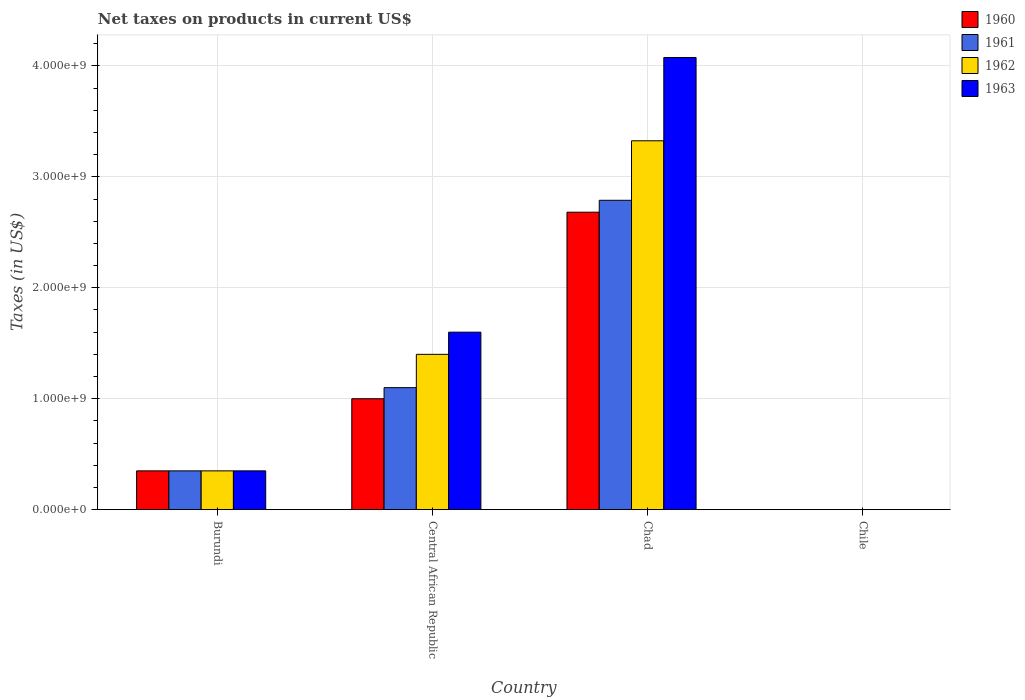How many different coloured bars are there?
Offer a terse response. 4. How many groups of bars are there?
Provide a short and direct response. 4. Are the number of bars per tick equal to the number of legend labels?
Provide a short and direct response. Yes. How many bars are there on the 3rd tick from the right?
Provide a short and direct response. 4. In how many cases, is the number of bars for a given country not equal to the number of legend labels?
Your answer should be compact. 0. What is the net taxes on products in 1963 in Chile?
Offer a terse response. 3.54e+05. Across all countries, what is the maximum net taxes on products in 1963?
Make the answer very short. 4.08e+09. Across all countries, what is the minimum net taxes on products in 1961?
Keep it short and to the point. 2.53e+05. In which country was the net taxes on products in 1961 maximum?
Give a very brief answer. Chad. In which country was the net taxes on products in 1962 minimum?
Make the answer very short. Chile. What is the total net taxes on products in 1962 in the graph?
Keep it short and to the point. 5.08e+09. What is the difference between the net taxes on products in 1960 in Central African Republic and that in Chile?
Keep it short and to the point. 1.00e+09. What is the difference between the net taxes on products in 1962 in Chad and the net taxes on products in 1963 in Chile?
Your answer should be very brief. 3.32e+09. What is the average net taxes on products in 1962 per country?
Your answer should be compact. 1.27e+09. What is the difference between the net taxes on products of/in 1960 and net taxes on products of/in 1961 in Chad?
Your answer should be compact. -1.07e+08. In how many countries, is the net taxes on products in 1960 greater than 1400000000 US$?
Give a very brief answer. 1. What is the ratio of the net taxes on products in 1962 in Burundi to that in Chad?
Offer a terse response. 0.11. Is the net taxes on products in 1962 in Burundi less than that in Central African Republic?
Offer a terse response. Yes. Is the difference between the net taxes on products in 1960 in Burundi and Central African Republic greater than the difference between the net taxes on products in 1961 in Burundi and Central African Republic?
Give a very brief answer. Yes. What is the difference between the highest and the second highest net taxes on products in 1963?
Offer a very short reply. 2.48e+09. What is the difference between the highest and the lowest net taxes on products in 1963?
Give a very brief answer. 4.08e+09. In how many countries, is the net taxes on products in 1963 greater than the average net taxes on products in 1963 taken over all countries?
Ensure brevity in your answer.  2. What does the 4th bar from the left in Chad represents?
Give a very brief answer. 1963. What does the 1st bar from the right in Burundi represents?
Keep it short and to the point. 1963. Is it the case that in every country, the sum of the net taxes on products in 1960 and net taxes on products in 1963 is greater than the net taxes on products in 1962?
Your response must be concise. Yes. How many countries are there in the graph?
Your response must be concise. 4. Are the values on the major ticks of Y-axis written in scientific E-notation?
Provide a succinct answer. Yes. Does the graph contain grids?
Offer a terse response. Yes. What is the title of the graph?
Your answer should be compact. Net taxes on products in current US$. Does "1960" appear as one of the legend labels in the graph?
Your answer should be very brief. Yes. What is the label or title of the X-axis?
Ensure brevity in your answer.  Country. What is the label or title of the Y-axis?
Keep it short and to the point. Taxes (in US$). What is the Taxes (in US$) in 1960 in Burundi?
Your answer should be compact. 3.50e+08. What is the Taxes (in US$) of 1961 in Burundi?
Give a very brief answer. 3.50e+08. What is the Taxes (in US$) of 1962 in Burundi?
Keep it short and to the point. 3.50e+08. What is the Taxes (in US$) of 1963 in Burundi?
Offer a terse response. 3.50e+08. What is the Taxes (in US$) of 1960 in Central African Republic?
Provide a succinct answer. 1.00e+09. What is the Taxes (in US$) in 1961 in Central African Republic?
Provide a succinct answer. 1.10e+09. What is the Taxes (in US$) of 1962 in Central African Republic?
Your answer should be compact. 1.40e+09. What is the Taxes (in US$) of 1963 in Central African Republic?
Provide a succinct answer. 1.60e+09. What is the Taxes (in US$) of 1960 in Chad?
Keep it short and to the point. 2.68e+09. What is the Taxes (in US$) in 1961 in Chad?
Ensure brevity in your answer.  2.79e+09. What is the Taxes (in US$) in 1962 in Chad?
Make the answer very short. 3.32e+09. What is the Taxes (in US$) in 1963 in Chad?
Ensure brevity in your answer.  4.08e+09. What is the Taxes (in US$) of 1960 in Chile?
Provide a short and direct response. 2.02e+05. What is the Taxes (in US$) in 1961 in Chile?
Keep it short and to the point. 2.53e+05. What is the Taxes (in US$) of 1962 in Chile?
Provide a short and direct response. 2.53e+05. What is the Taxes (in US$) of 1963 in Chile?
Make the answer very short. 3.54e+05. Across all countries, what is the maximum Taxes (in US$) in 1960?
Give a very brief answer. 2.68e+09. Across all countries, what is the maximum Taxes (in US$) of 1961?
Provide a succinct answer. 2.79e+09. Across all countries, what is the maximum Taxes (in US$) of 1962?
Offer a very short reply. 3.32e+09. Across all countries, what is the maximum Taxes (in US$) in 1963?
Make the answer very short. 4.08e+09. Across all countries, what is the minimum Taxes (in US$) of 1960?
Your response must be concise. 2.02e+05. Across all countries, what is the minimum Taxes (in US$) of 1961?
Ensure brevity in your answer.  2.53e+05. Across all countries, what is the minimum Taxes (in US$) in 1962?
Offer a very short reply. 2.53e+05. Across all countries, what is the minimum Taxes (in US$) of 1963?
Provide a succinct answer. 3.54e+05. What is the total Taxes (in US$) of 1960 in the graph?
Offer a very short reply. 4.03e+09. What is the total Taxes (in US$) in 1961 in the graph?
Your answer should be compact. 4.24e+09. What is the total Taxes (in US$) of 1962 in the graph?
Ensure brevity in your answer.  5.08e+09. What is the total Taxes (in US$) in 1963 in the graph?
Your response must be concise. 6.03e+09. What is the difference between the Taxes (in US$) in 1960 in Burundi and that in Central African Republic?
Offer a terse response. -6.50e+08. What is the difference between the Taxes (in US$) in 1961 in Burundi and that in Central African Republic?
Provide a succinct answer. -7.50e+08. What is the difference between the Taxes (in US$) in 1962 in Burundi and that in Central African Republic?
Provide a succinct answer. -1.05e+09. What is the difference between the Taxes (in US$) in 1963 in Burundi and that in Central African Republic?
Offer a terse response. -1.25e+09. What is the difference between the Taxes (in US$) of 1960 in Burundi and that in Chad?
Your response must be concise. -2.33e+09. What is the difference between the Taxes (in US$) in 1961 in Burundi and that in Chad?
Offer a terse response. -2.44e+09. What is the difference between the Taxes (in US$) in 1962 in Burundi and that in Chad?
Make the answer very short. -2.97e+09. What is the difference between the Taxes (in US$) in 1963 in Burundi and that in Chad?
Give a very brief answer. -3.73e+09. What is the difference between the Taxes (in US$) of 1960 in Burundi and that in Chile?
Offer a terse response. 3.50e+08. What is the difference between the Taxes (in US$) of 1961 in Burundi and that in Chile?
Ensure brevity in your answer.  3.50e+08. What is the difference between the Taxes (in US$) of 1962 in Burundi and that in Chile?
Offer a terse response. 3.50e+08. What is the difference between the Taxes (in US$) in 1963 in Burundi and that in Chile?
Give a very brief answer. 3.50e+08. What is the difference between the Taxes (in US$) in 1960 in Central African Republic and that in Chad?
Offer a terse response. -1.68e+09. What is the difference between the Taxes (in US$) in 1961 in Central African Republic and that in Chad?
Offer a terse response. -1.69e+09. What is the difference between the Taxes (in US$) of 1962 in Central African Republic and that in Chad?
Your answer should be compact. -1.92e+09. What is the difference between the Taxes (in US$) in 1963 in Central African Republic and that in Chad?
Ensure brevity in your answer.  -2.48e+09. What is the difference between the Taxes (in US$) in 1960 in Central African Republic and that in Chile?
Offer a terse response. 1.00e+09. What is the difference between the Taxes (in US$) of 1961 in Central African Republic and that in Chile?
Make the answer very short. 1.10e+09. What is the difference between the Taxes (in US$) in 1962 in Central African Republic and that in Chile?
Offer a very short reply. 1.40e+09. What is the difference between the Taxes (in US$) in 1963 in Central African Republic and that in Chile?
Offer a terse response. 1.60e+09. What is the difference between the Taxes (in US$) in 1960 in Chad and that in Chile?
Your answer should be very brief. 2.68e+09. What is the difference between the Taxes (in US$) of 1961 in Chad and that in Chile?
Provide a succinct answer. 2.79e+09. What is the difference between the Taxes (in US$) in 1962 in Chad and that in Chile?
Offer a terse response. 3.32e+09. What is the difference between the Taxes (in US$) of 1963 in Chad and that in Chile?
Your response must be concise. 4.08e+09. What is the difference between the Taxes (in US$) in 1960 in Burundi and the Taxes (in US$) in 1961 in Central African Republic?
Provide a succinct answer. -7.50e+08. What is the difference between the Taxes (in US$) of 1960 in Burundi and the Taxes (in US$) of 1962 in Central African Republic?
Provide a succinct answer. -1.05e+09. What is the difference between the Taxes (in US$) of 1960 in Burundi and the Taxes (in US$) of 1963 in Central African Republic?
Offer a very short reply. -1.25e+09. What is the difference between the Taxes (in US$) of 1961 in Burundi and the Taxes (in US$) of 1962 in Central African Republic?
Make the answer very short. -1.05e+09. What is the difference between the Taxes (in US$) in 1961 in Burundi and the Taxes (in US$) in 1963 in Central African Republic?
Make the answer very short. -1.25e+09. What is the difference between the Taxes (in US$) in 1962 in Burundi and the Taxes (in US$) in 1963 in Central African Republic?
Your answer should be very brief. -1.25e+09. What is the difference between the Taxes (in US$) in 1960 in Burundi and the Taxes (in US$) in 1961 in Chad?
Your answer should be compact. -2.44e+09. What is the difference between the Taxes (in US$) in 1960 in Burundi and the Taxes (in US$) in 1962 in Chad?
Your response must be concise. -2.97e+09. What is the difference between the Taxes (in US$) in 1960 in Burundi and the Taxes (in US$) in 1963 in Chad?
Provide a short and direct response. -3.73e+09. What is the difference between the Taxes (in US$) of 1961 in Burundi and the Taxes (in US$) of 1962 in Chad?
Provide a short and direct response. -2.97e+09. What is the difference between the Taxes (in US$) of 1961 in Burundi and the Taxes (in US$) of 1963 in Chad?
Your response must be concise. -3.73e+09. What is the difference between the Taxes (in US$) in 1962 in Burundi and the Taxes (in US$) in 1963 in Chad?
Provide a short and direct response. -3.73e+09. What is the difference between the Taxes (in US$) of 1960 in Burundi and the Taxes (in US$) of 1961 in Chile?
Your answer should be very brief. 3.50e+08. What is the difference between the Taxes (in US$) of 1960 in Burundi and the Taxes (in US$) of 1962 in Chile?
Your answer should be very brief. 3.50e+08. What is the difference between the Taxes (in US$) of 1960 in Burundi and the Taxes (in US$) of 1963 in Chile?
Offer a terse response. 3.50e+08. What is the difference between the Taxes (in US$) in 1961 in Burundi and the Taxes (in US$) in 1962 in Chile?
Offer a terse response. 3.50e+08. What is the difference between the Taxes (in US$) of 1961 in Burundi and the Taxes (in US$) of 1963 in Chile?
Keep it short and to the point. 3.50e+08. What is the difference between the Taxes (in US$) in 1962 in Burundi and the Taxes (in US$) in 1963 in Chile?
Give a very brief answer. 3.50e+08. What is the difference between the Taxes (in US$) of 1960 in Central African Republic and the Taxes (in US$) of 1961 in Chad?
Offer a very short reply. -1.79e+09. What is the difference between the Taxes (in US$) of 1960 in Central African Republic and the Taxes (in US$) of 1962 in Chad?
Provide a short and direct response. -2.32e+09. What is the difference between the Taxes (in US$) of 1960 in Central African Republic and the Taxes (in US$) of 1963 in Chad?
Give a very brief answer. -3.08e+09. What is the difference between the Taxes (in US$) in 1961 in Central African Republic and the Taxes (in US$) in 1962 in Chad?
Your answer should be very brief. -2.22e+09. What is the difference between the Taxes (in US$) of 1961 in Central African Republic and the Taxes (in US$) of 1963 in Chad?
Ensure brevity in your answer.  -2.98e+09. What is the difference between the Taxes (in US$) of 1962 in Central African Republic and the Taxes (in US$) of 1963 in Chad?
Give a very brief answer. -2.68e+09. What is the difference between the Taxes (in US$) of 1960 in Central African Republic and the Taxes (in US$) of 1961 in Chile?
Give a very brief answer. 1.00e+09. What is the difference between the Taxes (in US$) of 1960 in Central African Republic and the Taxes (in US$) of 1962 in Chile?
Provide a succinct answer. 1.00e+09. What is the difference between the Taxes (in US$) in 1960 in Central African Republic and the Taxes (in US$) in 1963 in Chile?
Offer a terse response. 1.00e+09. What is the difference between the Taxes (in US$) of 1961 in Central African Republic and the Taxes (in US$) of 1962 in Chile?
Ensure brevity in your answer.  1.10e+09. What is the difference between the Taxes (in US$) in 1961 in Central African Republic and the Taxes (in US$) in 1963 in Chile?
Your answer should be very brief. 1.10e+09. What is the difference between the Taxes (in US$) of 1962 in Central African Republic and the Taxes (in US$) of 1963 in Chile?
Your answer should be compact. 1.40e+09. What is the difference between the Taxes (in US$) of 1960 in Chad and the Taxes (in US$) of 1961 in Chile?
Provide a succinct answer. 2.68e+09. What is the difference between the Taxes (in US$) in 1960 in Chad and the Taxes (in US$) in 1962 in Chile?
Make the answer very short. 2.68e+09. What is the difference between the Taxes (in US$) in 1960 in Chad and the Taxes (in US$) in 1963 in Chile?
Make the answer very short. 2.68e+09. What is the difference between the Taxes (in US$) of 1961 in Chad and the Taxes (in US$) of 1962 in Chile?
Keep it short and to the point. 2.79e+09. What is the difference between the Taxes (in US$) of 1961 in Chad and the Taxes (in US$) of 1963 in Chile?
Offer a very short reply. 2.79e+09. What is the difference between the Taxes (in US$) in 1962 in Chad and the Taxes (in US$) in 1963 in Chile?
Offer a terse response. 3.32e+09. What is the average Taxes (in US$) of 1960 per country?
Keep it short and to the point. 1.01e+09. What is the average Taxes (in US$) of 1961 per country?
Your answer should be compact. 1.06e+09. What is the average Taxes (in US$) in 1962 per country?
Make the answer very short. 1.27e+09. What is the average Taxes (in US$) in 1963 per country?
Your answer should be very brief. 1.51e+09. What is the difference between the Taxes (in US$) of 1960 and Taxes (in US$) of 1961 in Burundi?
Offer a terse response. 0. What is the difference between the Taxes (in US$) of 1960 and Taxes (in US$) of 1963 in Burundi?
Your answer should be very brief. 0. What is the difference between the Taxes (in US$) in 1961 and Taxes (in US$) in 1963 in Burundi?
Your answer should be compact. 0. What is the difference between the Taxes (in US$) of 1960 and Taxes (in US$) of 1961 in Central African Republic?
Your response must be concise. -1.00e+08. What is the difference between the Taxes (in US$) in 1960 and Taxes (in US$) in 1962 in Central African Republic?
Provide a short and direct response. -4.00e+08. What is the difference between the Taxes (in US$) of 1960 and Taxes (in US$) of 1963 in Central African Republic?
Offer a terse response. -6.00e+08. What is the difference between the Taxes (in US$) in 1961 and Taxes (in US$) in 1962 in Central African Republic?
Offer a terse response. -3.00e+08. What is the difference between the Taxes (in US$) in 1961 and Taxes (in US$) in 1963 in Central African Republic?
Offer a terse response. -5.00e+08. What is the difference between the Taxes (in US$) of 1962 and Taxes (in US$) of 1963 in Central African Republic?
Offer a terse response. -2.00e+08. What is the difference between the Taxes (in US$) of 1960 and Taxes (in US$) of 1961 in Chad?
Your response must be concise. -1.07e+08. What is the difference between the Taxes (in US$) in 1960 and Taxes (in US$) in 1962 in Chad?
Ensure brevity in your answer.  -6.44e+08. What is the difference between the Taxes (in US$) of 1960 and Taxes (in US$) of 1963 in Chad?
Provide a succinct answer. -1.39e+09. What is the difference between the Taxes (in US$) of 1961 and Taxes (in US$) of 1962 in Chad?
Ensure brevity in your answer.  -5.36e+08. What is the difference between the Taxes (in US$) in 1961 and Taxes (in US$) in 1963 in Chad?
Provide a succinct answer. -1.29e+09. What is the difference between the Taxes (in US$) of 1962 and Taxes (in US$) of 1963 in Chad?
Offer a very short reply. -7.51e+08. What is the difference between the Taxes (in US$) in 1960 and Taxes (in US$) in 1961 in Chile?
Give a very brief answer. -5.06e+04. What is the difference between the Taxes (in US$) in 1960 and Taxes (in US$) in 1962 in Chile?
Keep it short and to the point. -5.06e+04. What is the difference between the Taxes (in US$) of 1960 and Taxes (in US$) of 1963 in Chile?
Offer a terse response. -1.52e+05. What is the difference between the Taxes (in US$) in 1961 and Taxes (in US$) in 1963 in Chile?
Provide a short and direct response. -1.01e+05. What is the difference between the Taxes (in US$) in 1962 and Taxes (in US$) in 1963 in Chile?
Offer a very short reply. -1.01e+05. What is the ratio of the Taxes (in US$) of 1961 in Burundi to that in Central African Republic?
Make the answer very short. 0.32. What is the ratio of the Taxes (in US$) in 1963 in Burundi to that in Central African Republic?
Ensure brevity in your answer.  0.22. What is the ratio of the Taxes (in US$) in 1960 in Burundi to that in Chad?
Ensure brevity in your answer.  0.13. What is the ratio of the Taxes (in US$) in 1961 in Burundi to that in Chad?
Make the answer very short. 0.13. What is the ratio of the Taxes (in US$) of 1962 in Burundi to that in Chad?
Offer a terse response. 0.11. What is the ratio of the Taxes (in US$) of 1963 in Burundi to that in Chad?
Your answer should be very brief. 0.09. What is the ratio of the Taxes (in US$) of 1960 in Burundi to that in Chile?
Make the answer very short. 1728.4. What is the ratio of the Taxes (in US$) in 1961 in Burundi to that in Chile?
Provide a short and direct response. 1382.85. What is the ratio of the Taxes (in US$) of 1962 in Burundi to that in Chile?
Keep it short and to the point. 1382.85. What is the ratio of the Taxes (in US$) in 1963 in Burundi to that in Chile?
Offer a very short reply. 987.58. What is the ratio of the Taxes (in US$) of 1960 in Central African Republic to that in Chad?
Your answer should be very brief. 0.37. What is the ratio of the Taxes (in US$) in 1961 in Central African Republic to that in Chad?
Make the answer very short. 0.39. What is the ratio of the Taxes (in US$) of 1962 in Central African Republic to that in Chad?
Offer a very short reply. 0.42. What is the ratio of the Taxes (in US$) of 1963 in Central African Republic to that in Chad?
Make the answer very short. 0.39. What is the ratio of the Taxes (in US$) of 1960 in Central African Republic to that in Chile?
Keep it short and to the point. 4938.27. What is the ratio of the Taxes (in US$) of 1961 in Central African Republic to that in Chile?
Ensure brevity in your answer.  4346.11. What is the ratio of the Taxes (in US$) in 1962 in Central African Republic to that in Chile?
Your answer should be very brief. 5531.41. What is the ratio of the Taxes (in US$) of 1963 in Central African Republic to that in Chile?
Give a very brief answer. 4514.67. What is the ratio of the Taxes (in US$) in 1960 in Chad to that in Chile?
Provide a short and direct response. 1.32e+04. What is the ratio of the Taxes (in US$) in 1961 in Chad to that in Chile?
Your answer should be compact. 1.10e+04. What is the ratio of the Taxes (in US$) in 1962 in Chad to that in Chile?
Your answer should be compact. 1.31e+04. What is the ratio of the Taxes (in US$) of 1963 in Chad to that in Chile?
Make the answer very short. 1.15e+04. What is the difference between the highest and the second highest Taxes (in US$) of 1960?
Offer a very short reply. 1.68e+09. What is the difference between the highest and the second highest Taxes (in US$) of 1961?
Your answer should be compact. 1.69e+09. What is the difference between the highest and the second highest Taxes (in US$) of 1962?
Your answer should be compact. 1.92e+09. What is the difference between the highest and the second highest Taxes (in US$) in 1963?
Your answer should be compact. 2.48e+09. What is the difference between the highest and the lowest Taxes (in US$) of 1960?
Offer a terse response. 2.68e+09. What is the difference between the highest and the lowest Taxes (in US$) of 1961?
Your answer should be compact. 2.79e+09. What is the difference between the highest and the lowest Taxes (in US$) of 1962?
Give a very brief answer. 3.32e+09. What is the difference between the highest and the lowest Taxes (in US$) of 1963?
Your answer should be compact. 4.08e+09. 